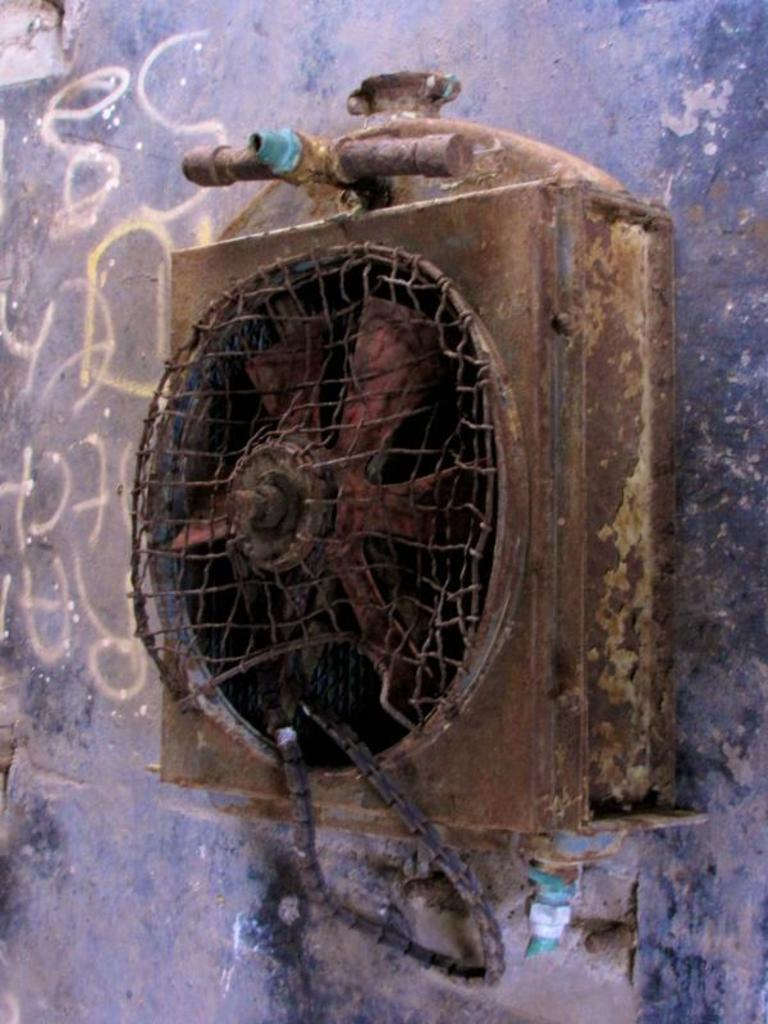What type of device is in the middle of the image? There is an electronic fan in the middle of the image. Where is the fan positioned in relation to the wall? The fan is attached to a wall. What color is the wall that the fan is attached to? The wall is blue. How many babies are crawling on the floor in the image? There are no babies present in the image; it features an electronic fan attached to a blue wall. What type of mark can be seen on the fan's blades? There is no mark visible on the fan's blades in the image. 